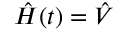Convert formula to latex. <formula><loc_0><loc_0><loc_500><loc_500>\hat { H } ( t ) = \hat { V }</formula> 